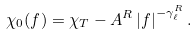Convert formula to latex. <formula><loc_0><loc_0><loc_500><loc_500>\chi _ { 0 } ( f ) = \chi _ { T } - A ^ { R } \left | f \right | ^ { - \gamma _ { \ell } ^ { R } } .</formula> 